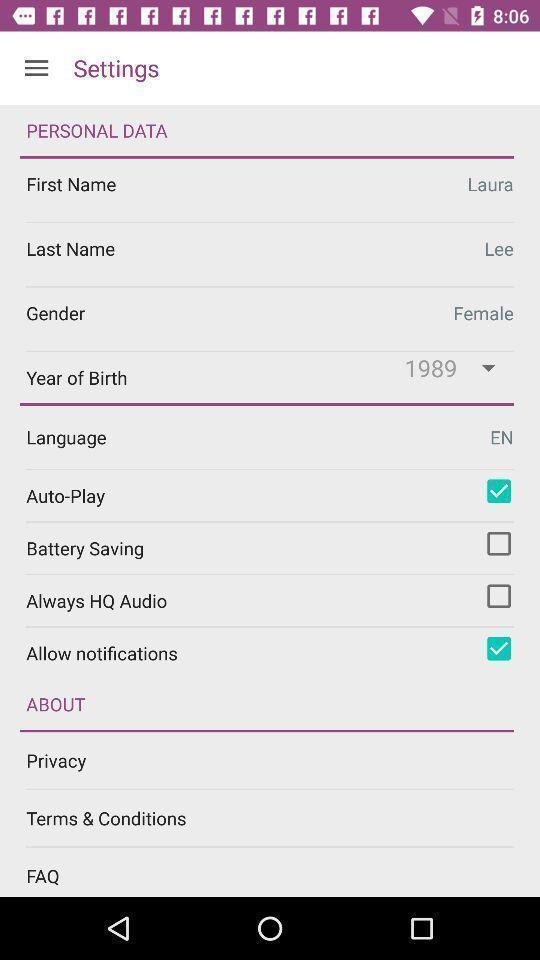Tell me about the visual elements in this screen capture. Settings page with personal data. 